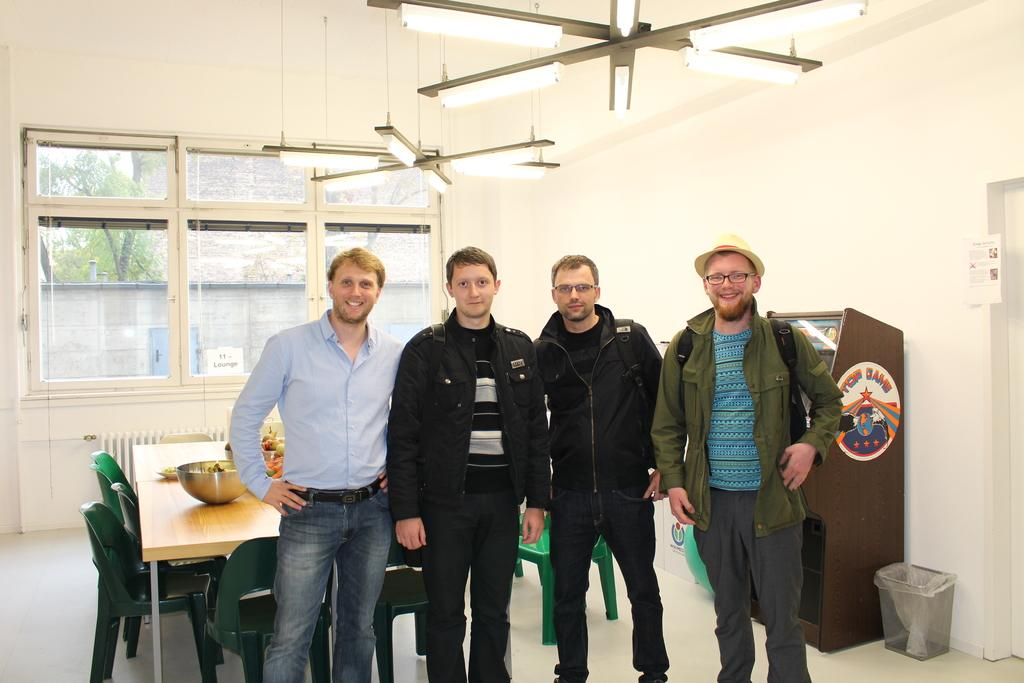How many people are in the image? There is a group of people in the image. What are the people doing in the image? The people are standing in the image. What is the main object in the image besides the people? There is a table in the image. What else can be seen in the image related to books or reading? There is a bookshelf in the image. What color is the dress worn by the balloon in the image? There is no balloon or dress present in the image. 